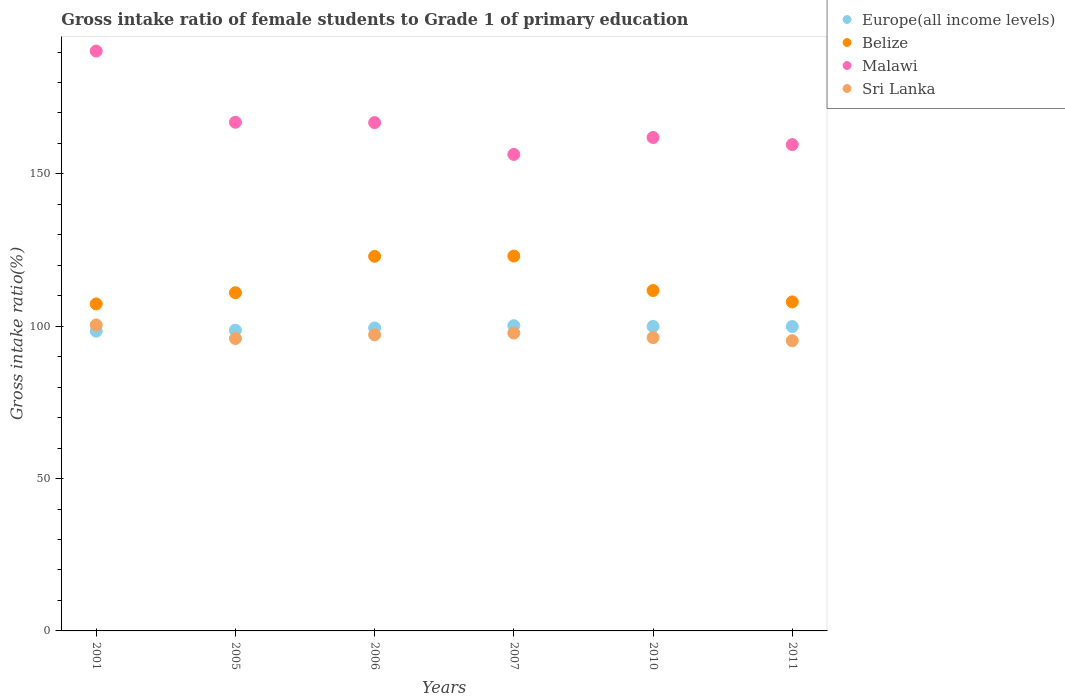How many different coloured dotlines are there?
Offer a very short reply. 4. What is the gross intake ratio in Sri Lanka in 2001?
Provide a succinct answer. 100.42. Across all years, what is the maximum gross intake ratio in Malawi?
Make the answer very short. 190.31. Across all years, what is the minimum gross intake ratio in Sri Lanka?
Give a very brief answer. 95.25. In which year was the gross intake ratio in Belize maximum?
Your response must be concise. 2007. What is the total gross intake ratio in Sri Lanka in the graph?
Your response must be concise. 582.84. What is the difference between the gross intake ratio in Belize in 2007 and that in 2011?
Keep it short and to the point. 15.05. What is the difference between the gross intake ratio in Belize in 2011 and the gross intake ratio in Sri Lanka in 2001?
Provide a short and direct response. 7.56. What is the average gross intake ratio in Europe(all income levels) per year?
Your answer should be compact. 99.42. In the year 2010, what is the difference between the gross intake ratio in Malawi and gross intake ratio in Belize?
Your response must be concise. 50.22. What is the ratio of the gross intake ratio in Sri Lanka in 2001 to that in 2010?
Your response must be concise. 1.04. Is the gross intake ratio in Europe(all income levels) in 2001 less than that in 2011?
Offer a terse response. Yes. Is the difference between the gross intake ratio in Malawi in 2005 and 2007 greater than the difference between the gross intake ratio in Belize in 2005 and 2007?
Your answer should be compact. Yes. What is the difference between the highest and the second highest gross intake ratio in Belize?
Your answer should be compact. 0.09. What is the difference between the highest and the lowest gross intake ratio in Europe(all income levels)?
Your answer should be compact. 1.79. Is it the case that in every year, the sum of the gross intake ratio in Belize and gross intake ratio in Europe(all income levels)  is greater than the sum of gross intake ratio in Malawi and gross intake ratio in Sri Lanka?
Provide a succinct answer. No. Is it the case that in every year, the sum of the gross intake ratio in Europe(all income levels) and gross intake ratio in Sri Lanka  is greater than the gross intake ratio in Belize?
Offer a very short reply. Yes. Does the gross intake ratio in Sri Lanka monotonically increase over the years?
Give a very brief answer. No. What is the difference between two consecutive major ticks on the Y-axis?
Give a very brief answer. 50. Are the values on the major ticks of Y-axis written in scientific E-notation?
Your answer should be compact. No. Where does the legend appear in the graph?
Provide a succinct answer. Top right. What is the title of the graph?
Give a very brief answer. Gross intake ratio of female students to Grade 1 of primary education. Does "Romania" appear as one of the legend labels in the graph?
Ensure brevity in your answer.  No. What is the label or title of the Y-axis?
Provide a short and direct response. Gross intake ratio(%). What is the Gross intake ratio(%) of Europe(all income levels) in 2001?
Offer a terse response. 98.39. What is the Gross intake ratio(%) in Belize in 2001?
Make the answer very short. 107.33. What is the Gross intake ratio(%) in Malawi in 2001?
Your answer should be compact. 190.31. What is the Gross intake ratio(%) in Sri Lanka in 2001?
Make the answer very short. 100.42. What is the Gross intake ratio(%) in Europe(all income levels) in 2005?
Provide a succinct answer. 98.7. What is the Gross intake ratio(%) of Belize in 2005?
Your answer should be compact. 111. What is the Gross intake ratio(%) of Malawi in 2005?
Ensure brevity in your answer.  166.94. What is the Gross intake ratio(%) of Sri Lanka in 2005?
Your answer should be compact. 95.96. What is the Gross intake ratio(%) in Europe(all income levels) in 2006?
Ensure brevity in your answer.  99.42. What is the Gross intake ratio(%) of Belize in 2006?
Provide a succinct answer. 122.94. What is the Gross intake ratio(%) in Malawi in 2006?
Your answer should be compact. 166.83. What is the Gross intake ratio(%) in Sri Lanka in 2006?
Ensure brevity in your answer.  97.18. What is the Gross intake ratio(%) in Europe(all income levels) in 2007?
Your answer should be compact. 100.18. What is the Gross intake ratio(%) in Belize in 2007?
Give a very brief answer. 123.03. What is the Gross intake ratio(%) in Malawi in 2007?
Your answer should be very brief. 156.38. What is the Gross intake ratio(%) in Sri Lanka in 2007?
Offer a very short reply. 97.76. What is the Gross intake ratio(%) in Europe(all income levels) in 2010?
Offer a terse response. 99.93. What is the Gross intake ratio(%) in Belize in 2010?
Your answer should be compact. 111.72. What is the Gross intake ratio(%) in Malawi in 2010?
Your answer should be compact. 161.95. What is the Gross intake ratio(%) in Sri Lanka in 2010?
Make the answer very short. 96.27. What is the Gross intake ratio(%) in Europe(all income levels) in 2011?
Provide a short and direct response. 99.91. What is the Gross intake ratio(%) in Belize in 2011?
Provide a short and direct response. 107.98. What is the Gross intake ratio(%) in Malawi in 2011?
Offer a very short reply. 159.61. What is the Gross intake ratio(%) of Sri Lanka in 2011?
Give a very brief answer. 95.25. Across all years, what is the maximum Gross intake ratio(%) in Europe(all income levels)?
Give a very brief answer. 100.18. Across all years, what is the maximum Gross intake ratio(%) in Belize?
Your answer should be very brief. 123.03. Across all years, what is the maximum Gross intake ratio(%) of Malawi?
Your answer should be very brief. 190.31. Across all years, what is the maximum Gross intake ratio(%) of Sri Lanka?
Your answer should be very brief. 100.42. Across all years, what is the minimum Gross intake ratio(%) of Europe(all income levels)?
Provide a succinct answer. 98.39. Across all years, what is the minimum Gross intake ratio(%) of Belize?
Ensure brevity in your answer.  107.33. Across all years, what is the minimum Gross intake ratio(%) of Malawi?
Offer a terse response. 156.38. Across all years, what is the minimum Gross intake ratio(%) of Sri Lanka?
Give a very brief answer. 95.25. What is the total Gross intake ratio(%) of Europe(all income levels) in the graph?
Keep it short and to the point. 596.53. What is the total Gross intake ratio(%) of Belize in the graph?
Keep it short and to the point. 684. What is the total Gross intake ratio(%) of Malawi in the graph?
Your answer should be very brief. 1002.03. What is the total Gross intake ratio(%) in Sri Lanka in the graph?
Make the answer very short. 582.84. What is the difference between the Gross intake ratio(%) in Europe(all income levels) in 2001 and that in 2005?
Your answer should be compact. -0.31. What is the difference between the Gross intake ratio(%) in Belize in 2001 and that in 2005?
Make the answer very short. -3.67. What is the difference between the Gross intake ratio(%) in Malawi in 2001 and that in 2005?
Ensure brevity in your answer.  23.37. What is the difference between the Gross intake ratio(%) in Sri Lanka in 2001 and that in 2005?
Give a very brief answer. 4.46. What is the difference between the Gross intake ratio(%) in Europe(all income levels) in 2001 and that in 2006?
Offer a very short reply. -1.03. What is the difference between the Gross intake ratio(%) of Belize in 2001 and that in 2006?
Provide a short and direct response. -15.62. What is the difference between the Gross intake ratio(%) of Malawi in 2001 and that in 2006?
Ensure brevity in your answer.  23.48. What is the difference between the Gross intake ratio(%) of Sri Lanka in 2001 and that in 2006?
Provide a succinct answer. 3.24. What is the difference between the Gross intake ratio(%) in Europe(all income levels) in 2001 and that in 2007?
Your response must be concise. -1.79. What is the difference between the Gross intake ratio(%) in Belize in 2001 and that in 2007?
Ensure brevity in your answer.  -15.71. What is the difference between the Gross intake ratio(%) in Malawi in 2001 and that in 2007?
Offer a very short reply. 33.93. What is the difference between the Gross intake ratio(%) of Sri Lanka in 2001 and that in 2007?
Give a very brief answer. 2.65. What is the difference between the Gross intake ratio(%) of Europe(all income levels) in 2001 and that in 2010?
Your answer should be very brief. -1.55. What is the difference between the Gross intake ratio(%) in Belize in 2001 and that in 2010?
Keep it short and to the point. -4.4. What is the difference between the Gross intake ratio(%) of Malawi in 2001 and that in 2010?
Offer a very short reply. 28.37. What is the difference between the Gross intake ratio(%) in Sri Lanka in 2001 and that in 2010?
Your answer should be compact. 4.15. What is the difference between the Gross intake ratio(%) in Europe(all income levels) in 2001 and that in 2011?
Provide a succinct answer. -1.53. What is the difference between the Gross intake ratio(%) of Belize in 2001 and that in 2011?
Keep it short and to the point. -0.65. What is the difference between the Gross intake ratio(%) of Malawi in 2001 and that in 2011?
Offer a terse response. 30.7. What is the difference between the Gross intake ratio(%) in Sri Lanka in 2001 and that in 2011?
Your answer should be compact. 5.17. What is the difference between the Gross intake ratio(%) of Europe(all income levels) in 2005 and that in 2006?
Your response must be concise. -0.72. What is the difference between the Gross intake ratio(%) in Belize in 2005 and that in 2006?
Keep it short and to the point. -11.94. What is the difference between the Gross intake ratio(%) of Malawi in 2005 and that in 2006?
Provide a succinct answer. 0.12. What is the difference between the Gross intake ratio(%) of Sri Lanka in 2005 and that in 2006?
Offer a very short reply. -1.22. What is the difference between the Gross intake ratio(%) in Europe(all income levels) in 2005 and that in 2007?
Offer a very short reply. -1.48. What is the difference between the Gross intake ratio(%) in Belize in 2005 and that in 2007?
Your response must be concise. -12.03. What is the difference between the Gross intake ratio(%) in Malawi in 2005 and that in 2007?
Provide a short and direct response. 10.56. What is the difference between the Gross intake ratio(%) of Sri Lanka in 2005 and that in 2007?
Give a very brief answer. -1.8. What is the difference between the Gross intake ratio(%) of Europe(all income levels) in 2005 and that in 2010?
Provide a short and direct response. -1.23. What is the difference between the Gross intake ratio(%) of Belize in 2005 and that in 2010?
Make the answer very short. -0.72. What is the difference between the Gross intake ratio(%) in Malawi in 2005 and that in 2010?
Your answer should be compact. 5. What is the difference between the Gross intake ratio(%) of Sri Lanka in 2005 and that in 2010?
Your response must be concise. -0.31. What is the difference between the Gross intake ratio(%) of Europe(all income levels) in 2005 and that in 2011?
Provide a succinct answer. -1.22. What is the difference between the Gross intake ratio(%) of Belize in 2005 and that in 2011?
Offer a terse response. 3.02. What is the difference between the Gross intake ratio(%) of Malawi in 2005 and that in 2011?
Offer a very short reply. 7.34. What is the difference between the Gross intake ratio(%) of Sri Lanka in 2005 and that in 2011?
Provide a short and direct response. 0.71. What is the difference between the Gross intake ratio(%) in Europe(all income levels) in 2006 and that in 2007?
Your answer should be compact. -0.76. What is the difference between the Gross intake ratio(%) of Belize in 2006 and that in 2007?
Ensure brevity in your answer.  -0.09. What is the difference between the Gross intake ratio(%) of Malawi in 2006 and that in 2007?
Provide a succinct answer. 10.45. What is the difference between the Gross intake ratio(%) in Sri Lanka in 2006 and that in 2007?
Ensure brevity in your answer.  -0.58. What is the difference between the Gross intake ratio(%) of Europe(all income levels) in 2006 and that in 2010?
Ensure brevity in your answer.  -0.51. What is the difference between the Gross intake ratio(%) of Belize in 2006 and that in 2010?
Your answer should be very brief. 11.22. What is the difference between the Gross intake ratio(%) in Malawi in 2006 and that in 2010?
Your answer should be compact. 4.88. What is the difference between the Gross intake ratio(%) in Sri Lanka in 2006 and that in 2010?
Offer a terse response. 0.91. What is the difference between the Gross intake ratio(%) in Europe(all income levels) in 2006 and that in 2011?
Offer a very short reply. -0.49. What is the difference between the Gross intake ratio(%) of Belize in 2006 and that in 2011?
Ensure brevity in your answer.  14.96. What is the difference between the Gross intake ratio(%) of Malawi in 2006 and that in 2011?
Provide a short and direct response. 7.22. What is the difference between the Gross intake ratio(%) of Sri Lanka in 2006 and that in 2011?
Provide a succinct answer. 1.93. What is the difference between the Gross intake ratio(%) of Europe(all income levels) in 2007 and that in 2010?
Your response must be concise. 0.25. What is the difference between the Gross intake ratio(%) of Belize in 2007 and that in 2010?
Keep it short and to the point. 11.31. What is the difference between the Gross intake ratio(%) of Malawi in 2007 and that in 2010?
Provide a short and direct response. -5.56. What is the difference between the Gross intake ratio(%) in Sri Lanka in 2007 and that in 2010?
Offer a terse response. 1.49. What is the difference between the Gross intake ratio(%) in Europe(all income levels) in 2007 and that in 2011?
Your answer should be compact. 0.27. What is the difference between the Gross intake ratio(%) of Belize in 2007 and that in 2011?
Offer a very short reply. 15.05. What is the difference between the Gross intake ratio(%) in Malawi in 2007 and that in 2011?
Your response must be concise. -3.23. What is the difference between the Gross intake ratio(%) of Sri Lanka in 2007 and that in 2011?
Offer a terse response. 2.52. What is the difference between the Gross intake ratio(%) of Europe(all income levels) in 2010 and that in 2011?
Provide a short and direct response. 0.02. What is the difference between the Gross intake ratio(%) of Belize in 2010 and that in 2011?
Provide a succinct answer. 3.74. What is the difference between the Gross intake ratio(%) in Malawi in 2010 and that in 2011?
Your answer should be very brief. 2.34. What is the difference between the Gross intake ratio(%) of Sri Lanka in 2010 and that in 2011?
Offer a very short reply. 1.02. What is the difference between the Gross intake ratio(%) in Europe(all income levels) in 2001 and the Gross intake ratio(%) in Belize in 2005?
Give a very brief answer. -12.61. What is the difference between the Gross intake ratio(%) in Europe(all income levels) in 2001 and the Gross intake ratio(%) in Malawi in 2005?
Offer a terse response. -68.56. What is the difference between the Gross intake ratio(%) in Europe(all income levels) in 2001 and the Gross intake ratio(%) in Sri Lanka in 2005?
Provide a short and direct response. 2.43. What is the difference between the Gross intake ratio(%) of Belize in 2001 and the Gross intake ratio(%) of Malawi in 2005?
Offer a very short reply. -59.62. What is the difference between the Gross intake ratio(%) in Belize in 2001 and the Gross intake ratio(%) in Sri Lanka in 2005?
Keep it short and to the point. 11.36. What is the difference between the Gross intake ratio(%) of Malawi in 2001 and the Gross intake ratio(%) of Sri Lanka in 2005?
Offer a terse response. 94.35. What is the difference between the Gross intake ratio(%) of Europe(all income levels) in 2001 and the Gross intake ratio(%) of Belize in 2006?
Provide a succinct answer. -24.56. What is the difference between the Gross intake ratio(%) in Europe(all income levels) in 2001 and the Gross intake ratio(%) in Malawi in 2006?
Offer a very short reply. -68.44. What is the difference between the Gross intake ratio(%) in Europe(all income levels) in 2001 and the Gross intake ratio(%) in Sri Lanka in 2006?
Your response must be concise. 1.2. What is the difference between the Gross intake ratio(%) in Belize in 2001 and the Gross intake ratio(%) in Malawi in 2006?
Keep it short and to the point. -59.5. What is the difference between the Gross intake ratio(%) of Belize in 2001 and the Gross intake ratio(%) of Sri Lanka in 2006?
Ensure brevity in your answer.  10.14. What is the difference between the Gross intake ratio(%) of Malawi in 2001 and the Gross intake ratio(%) of Sri Lanka in 2006?
Provide a succinct answer. 93.13. What is the difference between the Gross intake ratio(%) in Europe(all income levels) in 2001 and the Gross intake ratio(%) in Belize in 2007?
Keep it short and to the point. -24.65. What is the difference between the Gross intake ratio(%) in Europe(all income levels) in 2001 and the Gross intake ratio(%) in Malawi in 2007?
Provide a short and direct response. -58. What is the difference between the Gross intake ratio(%) of Europe(all income levels) in 2001 and the Gross intake ratio(%) of Sri Lanka in 2007?
Provide a short and direct response. 0.62. What is the difference between the Gross intake ratio(%) in Belize in 2001 and the Gross intake ratio(%) in Malawi in 2007?
Your response must be concise. -49.06. What is the difference between the Gross intake ratio(%) of Belize in 2001 and the Gross intake ratio(%) of Sri Lanka in 2007?
Make the answer very short. 9.56. What is the difference between the Gross intake ratio(%) of Malawi in 2001 and the Gross intake ratio(%) of Sri Lanka in 2007?
Keep it short and to the point. 92.55. What is the difference between the Gross intake ratio(%) of Europe(all income levels) in 2001 and the Gross intake ratio(%) of Belize in 2010?
Ensure brevity in your answer.  -13.34. What is the difference between the Gross intake ratio(%) in Europe(all income levels) in 2001 and the Gross intake ratio(%) in Malawi in 2010?
Keep it short and to the point. -63.56. What is the difference between the Gross intake ratio(%) in Europe(all income levels) in 2001 and the Gross intake ratio(%) in Sri Lanka in 2010?
Offer a terse response. 2.12. What is the difference between the Gross intake ratio(%) in Belize in 2001 and the Gross intake ratio(%) in Malawi in 2010?
Offer a very short reply. -54.62. What is the difference between the Gross intake ratio(%) in Belize in 2001 and the Gross intake ratio(%) in Sri Lanka in 2010?
Your answer should be very brief. 11.06. What is the difference between the Gross intake ratio(%) of Malawi in 2001 and the Gross intake ratio(%) of Sri Lanka in 2010?
Ensure brevity in your answer.  94.04. What is the difference between the Gross intake ratio(%) of Europe(all income levels) in 2001 and the Gross intake ratio(%) of Belize in 2011?
Give a very brief answer. -9.59. What is the difference between the Gross intake ratio(%) in Europe(all income levels) in 2001 and the Gross intake ratio(%) in Malawi in 2011?
Your response must be concise. -61.22. What is the difference between the Gross intake ratio(%) in Europe(all income levels) in 2001 and the Gross intake ratio(%) in Sri Lanka in 2011?
Ensure brevity in your answer.  3.14. What is the difference between the Gross intake ratio(%) of Belize in 2001 and the Gross intake ratio(%) of Malawi in 2011?
Ensure brevity in your answer.  -52.28. What is the difference between the Gross intake ratio(%) of Belize in 2001 and the Gross intake ratio(%) of Sri Lanka in 2011?
Make the answer very short. 12.08. What is the difference between the Gross intake ratio(%) in Malawi in 2001 and the Gross intake ratio(%) in Sri Lanka in 2011?
Your answer should be compact. 95.06. What is the difference between the Gross intake ratio(%) in Europe(all income levels) in 2005 and the Gross intake ratio(%) in Belize in 2006?
Your answer should be very brief. -24.25. What is the difference between the Gross intake ratio(%) in Europe(all income levels) in 2005 and the Gross intake ratio(%) in Malawi in 2006?
Your answer should be very brief. -68.13. What is the difference between the Gross intake ratio(%) of Europe(all income levels) in 2005 and the Gross intake ratio(%) of Sri Lanka in 2006?
Make the answer very short. 1.52. What is the difference between the Gross intake ratio(%) of Belize in 2005 and the Gross intake ratio(%) of Malawi in 2006?
Offer a terse response. -55.83. What is the difference between the Gross intake ratio(%) of Belize in 2005 and the Gross intake ratio(%) of Sri Lanka in 2006?
Your answer should be compact. 13.82. What is the difference between the Gross intake ratio(%) in Malawi in 2005 and the Gross intake ratio(%) in Sri Lanka in 2006?
Keep it short and to the point. 69.76. What is the difference between the Gross intake ratio(%) in Europe(all income levels) in 2005 and the Gross intake ratio(%) in Belize in 2007?
Your response must be concise. -24.34. What is the difference between the Gross intake ratio(%) of Europe(all income levels) in 2005 and the Gross intake ratio(%) of Malawi in 2007?
Provide a succinct answer. -57.69. What is the difference between the Gross intake ratio(%) in Europe(all income levels) in 2005 and the Gross intake ratio(%) in Sri Lanka in 2007?
Provide a succinct answer. 0.93. What is the difference between the Gross intake ratio(%) of Belize in 2005 and the Gross intake ratio(%) of Malawi in 2007?
Make the answer very short. -45.38. What is the difference between the Gross intake ratio(%) in Belize in 2005 and the Gross intake ratio(%) in Sri Lanka in 2007?
Provide a succinct answer. 13.24. What is the difference between the Gross intake ratio(%) in Malawi in 2005 and the Gross intake ratio(%) in Sri Lanka in 2007?
Provide a short and direct response. 69.18. What is the difference between the Gross intake ratio(%) of Europe(all income levels) in 2005 and the Gross intake ratio(%) of Belize in 2010?
Ensure brevity in your answer.  -13.03. What is the difference between the Gross intake ratio(%) of Europe(all income levels) in 2005 and the Gross intake ratio(%) of Malawi in 2010?
Provide a succinct answer. -63.25. What is the difference between the Gross intake ratio(%) of Europe(all income levels) in 2005 and the Gross intake ratio(%) of Sri Lanka in 2010?
Your response must be concise. 2.43. What is the difference between the Gross intake ratio(%) of Belize in 2005 and the Gross intake ratio(%) of Malawi in 2010?
Your response must be concise. -50.95. What is the difference between the Gross intake ratio(%) of Belize in 2005 and the Gross intake ratio(%) of Sri Lanka in 2010?
Your answer should be very brief. 14.73. What is the difference between the Gross intake ratio(%) of Malawi in 2005 and the Gross intake ratio(%) of Sri Lanka in 2010?
Your answer should be very brief. 70.68. What is the difference between the Gross intake ratio(%) of Europe(all income levels) in 2005 and the Gross intake ratio(%) of Belize in 2011?
Ensure brevity in your answer.  -9.28. What is the difference between the Gross intake ratio(%) of Europe(all income levels) in 2005 and the Gross intake ratio(%) of Malawi in 2011?
Ensure brevity in your answer.  -60.91. What is the difference between the Gross intake ratio(%) in Europe(all income levels) in 2005 and the Gross intake ratio(%) in Sri Lanka in 2011?
Your answer should be very brief. 3.45. What is the difference between the Gross intake ratio(%) of Belize in 2005 and the Gross intake ratio(%) of Malawi in 2011?
Offer a very short reply. -48.61. What is the difference between the Gross intake ratio(%) in Belize in 2005 and the Gross intake ratio(%) in Sri Lanka in 2011?
Provide a short and direct response. 15.75. What is the difference between the Gross intake ratio(%) of Malawi in 2005 and the Gross intake ratio(%) of Sri Lanka in 2011?
Offer a terse response. 71.7. What is the difference between the Gross intake ratio(%) in Europe(all income levels) in 2006 and the Gross intake ratio(%) in Belize in 2007?
Your answer should be very brief. -23.61. What is the difference between the Gross intake ratio(%) of Europe(all income levels) in 2006 and the Gross intake ratio(%) of Malawi in 2007?
Your answer should be compact. -56.96. What is the difference between the Gross intake ratio(%) in Europe(all income levels) in 2006 and the Gross intake ratio(%) in Sri Lanka in 2007?
Provide a short and direct response. 1.66. What is the difference between the Gross intake ratio(%) in Belize in 2006 and the Gross intake ratio(%) in Malawi in 2007?
Ensure brevity in your answer.  -33.44. What is the difference between the Gross intake ratio(%) of Belize in 2006 and the Gross intake ratio(%) of Sri Lanka in 2007?
Provide a short and direct response. 25.18. What is the difference between the Gross intake ratio(%) of Malawi in 2006 and the Gross intake ratio(%) of Sri Lanka in 2007?
Your answer should be very brief. 69.07. What is the difference between the Gross intake ratio(%) of Europe(all income levels) in 2006 and the Gross intake ratio(%) of Belize in 2010?
Provide a succinct answer. -12.3. What is the difference between the Gross intake ratio(%) in Europe(all income levels) in 2006 and the Gross intake ratio(%) in Malawi in 2010?
Your response must be concise. -62.53. What is the difference between the Gross intake ratio(%) in Europe(all income levels) in 2006 and the Gross intake ratio(%) in Sri Lanka in 2010?
Provide a short and direct response. 3.15. What is the difference between the Gross intake ratio(%) in Belize in 2006 and the Gross intake ratio(%) in Malawi in 2010?
Your answer should be compact. -39. What is the difference between the Gross intake ratio(%) of Belize in 2006 and the Gross intake ratio(%) of Sri Lanka in 2010?
Your answer should be compact. 26.67. What is the difference between the Gross intake ratio(%) in Malawi in 2006 and the Gross intake ratio(%) in Sri Lanka in 2010?
Your answer should be compact. 70.56. What is the difference between the Gross intake ratio(%) of Europe(all income levels) in 2006 and the Gross intake ratio(%) of Belize in 2011?
Your response must be concise. -8.56. What is the difference between the Gross intake ratio(%) of Europe(all income levels) in 2006 and the Gross intake ratio(%) of Malawi in 2011?
Make the answer very short. -60.19. What is the difference between the Gross intake ratio(%) of Europe(all income levels) in 2006 and the Gross intake ratio(%) of Sri Lanka in 2011?
Offer a very short reply. 4.17. What is the difference between the Gross intake ratio(%) in Belize in 2006 and the Gross intake ratio(%) in Malawi in 2011?
Keep it short and to the point. -36.67. What is the difference between the Gross intake ratio(%) in Belize in 2006 and the Gross intake ratio(%) in Sri Lanka in 2011?
Your answer should be very brief. 27.69. What is the difference between the Gross intake ratio(%) of Malawi in 2006 and the Gross intake ratio(%) of Sri Lanka in 2011?
Offer a terse response. 71.58. What is the difference between the Gross intake ratio(%) in Europe(all income levels) in 2007 and the Gross intake ratio(%) in Belize in 2010?
Give a very brief answer. -11.54. What is the difference between the Gross intake ratio(%) of Europe(all income levels) in 2007 and the Gross intake ratio(%) of Malawi in 2010?
Ensure brevity in your answer.  -61.77. What is the difference between the Gross intake ratio(%) of Europe(all income levels) in 2007 and the Gross intake ratio(%) of Sri Lanka in 2010?
Your answer should be compact. 3.91. What is the difference between the Gross intake ratio(%) in Belize in 2007 and the Gross intake ratio(%) in Malawi in 2010?
Provide a short and direct response. -38.91. What is the difference between the Gross intake ratio(%) of Belize in 2007 and the Gross intake ratio(%) of Sri Lanka in 2010?
Offer a very short reply. 26.76. What is the difference between the Gross intake ratio(%) in Malawi in 2007 and the Gross intake ratio(%) in Sri Lanka in 2010?
Your response must be concise. 60.11. What is the difference between the Gross intake ratio(%) of Europe(all income levels) in 2007 and the Gross intake ratio(%) of Belize in 2011?
Your response must be concise. -7.8. What is the difference between the Gross intake ratio(%) in Europe(all income levels) in 2007 and the Gross intake ratio(%) in Malawi in 2011?
Your answer should be compact. -59.43. What is the difference between the Gross intake ratio(%) in Europe(all income levels) in 2007 and the Gross intake ratio(%) in Sri Lanka in 2011?
Provide a succinct answer. 4.93. What is the difference between the Gross intake ratio(%) of Belize in 2007 and the Gross intake ratio(%) of Malawi in 2011?
Your response must be concise. -36.58. What is the difference between the Gross intake ratio(%) in Belize in 2007 and the Gross intake ratio(%) in Sri Lanka in 2011?
Make the answer very short. 27.79. What is the difference between the Gross intake ratio(%) in Malawi in 2007 and the Gross intake ratio(%) in Sri Lanka in 2011?
Your response must be concise. 61.13. What is the difference between the Gross intake ratio(%) of Europe(all income levels) in 2010 and the Gross intake ratio(%) of Belize in 2011?
Ensure brevity in your answer.  -8.05. What is the difference between the Gross intake ratio(%) of Europe(all income levels) in 2010 and the Gross intake ratio(%) of Malawi in 2011?
Offer a terse response. -59.68. What is the difference between the Gross intake ratio(%) in Europe(all income levels) in 2010 and the Gross intake ratio(%) in Sri Lanka in 2011?
Your answer should be very brief. 4.68. What is the difference between the Gross intake ratio(%) in Belize in 2010 and the Gross intake ratio(%) in Malawi in 2011?
Ensure brevity in your answer.  -47.89. What is the difference between the Gross intake ratio(%) in Belize in 2010 and the Gross intake ratio(%) in Sri Lanka in 2011?
Make the answer very short. 16.47. What is the difference between the Gross intake ratio(%) of Malawi in 2010 and the Gross intake ratio(%) of Sri Lanka in 2011?
Make the answer very short. 66.7. What is the average Gross intake ratio(%) in Europe(all income levels) per year?
Offer a very short reply. 99.42. What is the average Gross intake ratio(%) of Belize per year?
Your answer should be very brief. 114. What is the average Gross intake ratio(%) in Malawi per year?
Ensure brevity in your answer.  167. What is the average Gross intake ratio(%) of Sri Lanka per year?
Your answer should be very brief. 97.14. In the year 2001, what is the difference between the Gross intake ratio(%) in Europe(all income levels) and Gross intake ratio(%) in Belize?
Keep it short and to the point. -8.94. In the year 2001, what is the difference between the Gross intake ratio(%) of Europe(all income levels) and Gross intake ratio(%) of Malawi?
Keep it short and to the point. -91.93. In the year 2001, what is the difference between the Gross intake ratio(%) in Europe(all income levels) and Gross intake ratio(%) in Sri Lanka?
Your response must be concise. -2.03. In the year 2001, what is the difference between the Gross intake ratio(%) of Belize and Gross intake ratio(%) of Malawi?
Provide a succinct answer. -82.99. In the year 2001, what is the difference between the Gross intake ratio(%) of Belize and Gross intake ratio(%) of Sri Lanka?
Make the answer very short. 6.91. In the year 2001, what is the difference between the Gross intake ratio(%) of Malawi and Gross intake ratio(%) of Sri Lanka?
Offer a very short reply. 89.89. In the year 2005, what is the difference between the Gross intake ratio(%) in Europe(all income levels) and Gross intake ratio(%) in Belize?
Offer a very short reply. -12.3. In the year 2005, what is the difference between the Gross intake ratio(%) in Europe(all income levels) and Gross intake ratio(%) in Malawi?
Your answer should be compact. -68.25. In the year 2005, what is the difference between the Gross intake ratio(%) in Europe(all income levels) and Gross intake ratio(%) in Sri Lanka?
Give a very brief answer. 2.74. In the year 2005, what is the difference between the Gross intake ratio(%) in Belize and Gross intake ratio(%) in Malawi?
Offer a very short reply. -55.94. In the year 2005, what is the difference between the Gross intake ratio(%) in Belize and Gross intake ratio(%) in Sri Lanka?
Provide a short and direct response. 15.04. In the year 2005, what is the difference between the Gross intake ratio(%) of Malawi and Gross intake ratio(%) of Sri Lanka?
Your answer should be very brief. 70.98. In the year 2006, what is the difference between the Gross intake ratio(%) of Europe(all income levels) and Gross intake ratio(%) of Belize?
Offer a terse response. -23.52. In the year 2006, what is the difference between the Gross intake ratio(%) of Europe(all income levels) and Gross intake ratio(%) of Malawi?
Make the answer very short. -67.41. In the year 2006, what is the difference between the Gross intake ratio(%) in Europe(all income levels) and Gross intake ratio(%) in Sri Lanka?
Give a very brief answer. 2.24. In the year 2006, what is the difference between the Gross intake ratio(%) of Belize and Gross intake ratio(%) of Malawi?
Keep it short and to the point. -43.89. In the year 2006, what is the difference between the Gross intake ratio(%) in Belize and Gross intake ratio(%) in Sri Lanka?
Offer a very short reply. 25.76. In the year 2006, what is the difference between the Gross intake ratio(%) in Malawi and Gross intake ratio(%) in Sri Lanka?
Ensure brevity in your answer.  69.65. In the year 2007, what is the difference between the Gross intake ratio(%) in Europe(all income levels) and Gross intake ratio(%) in Belize?
Keep it short and to the point. -22.85. In the year 2007, what is the difference between the Gross intake ratio(%) of Europe(all income levels) and Gross intake ratio(%) of Malawi?
Offer a very short reply. -56.2. In the year 2007, what is the difference between the Gross intake ratio(%) in Europe(all income levels) and Gross intake ratio(%) in Sri Lanka?
Your answer should be very brief. 2.42. In the year 2007, what is the difference between the Gross intake ratio(%) of Belize and Gross intake ratio(%) of Malawi?
Offer a terse response. -33.35. In the year 2007, what is the difference between the Gross intake ratio(%) of Belize and Gross intake ratio(%) of Sri Lanka?
Give a very brief answer. 25.27. In the year 2007, what is the difference between the Gross intake ratio(%) of Malawi and Gross intake ratio(%) of Sri Lanka?
Provide a succinct answer. 58.62. In the year 2010, what is the difference between the Gross intake ratio(%) of Europe(all income levels) and Gross intake ratio(%) of Belize?
Your response must be concise. -11.79. In the year 2010, what is the difference between the Gross intake ratio(%) of Europe(all income levels) and Gross intake ratio(%) of Malawi?
Make the answer very short. -62.02. In the year 2010, what is the difference between the Gross intake ratio(%) of Europe(all income levels) and Gross intake ratio(%) of Sri Lanka?
Provide a succinct answer. 3.66. In the year 2010, what is the difference between the Gross intake ratio(%) in Belize and Gross intake ratio(%) in Malawi?
Your response must be concise. -50.22. In the year 2010, what is the difference between the Gross intake ratio(%) of Belize and Gross intake ratio(%) of Sri Lanka?
Keep it short and to the point. 15.45. In the year 2010, what is the difference between the Gross intake ratio(%) in Malawi and Gross intake ratio(%) in Sri Lanka?
Your response must be concise. 65.68. In the year 2011, what is the difference between the Gross intake ratio(%) of Europe(all income levels) and Gross intake ratio(%) of Belize?
Give a very brief answer. -8.06. In the year 2011, what is the difference between the Gross intake ratio(%) of Europe(all income levels) and Gross intake ratio(%) of Malawi?
Give a very brief answer. -59.7. In the year 2011, what is the difference between the Gross intake ratio(%) in Europe(all income levels) and Gross intake ratio(%) in Sri Lanka?
Keep it short and to the point. 4.67. In the year 2011, what is the difference between the Gross intake ratio(%) of Belize and Gross intake ratio(%) of Malawi?
Your response must be concise. -51.63. In the year 2011, what is the difference between the Gross intake ratio(%) in Belize and Gross intake ratio(%) in Sri Lanka?
Your response must be concise. 12.73. In the year 2011, what is the difference between the Gross intake ratio(%) in Malawi and Gross intake ratio(%) in Sri Lanka?
Provide a short and direct response. 64.36. What is the ratio of the Gross intake ratio(%) in Belize in 2001 to that in 2005?
Provide a succinct answer. 0.97. What is the ratio of the Gross intake ratio(%) of Malawi in 2001 to that in 2005?
Provide a succinct answer. 1.14. What is the ratio of the Gross intake ratio(%) in Sri Lanka in 2001 to that in 2005?
Provide a short and direct response. 1.05. What is the ratio of the Gross intake ratio(%) of Europe(all income levels) in 2001 to that in 2006?
Provide a succinct answer. 0.99. What is the ratio of the Gross intake ratio(%) of Belize in 2001 to that in 2006?
Make the answer very short. 0.87. What is the ratio of the Gross intake ratio(%) of Malawi in 2001 to that in 2006?
Your answer should be compact. 1.14. What is the ratio of the Gross intake ratio(%) in Europe(all income levels) in 2001 to that in 2007?
Provide a short and direct response. 0.98. What is the ratio of the Gross intake ratio(%) in Belize in 2001 to that in 2007?
Give a very brief answer. 0.87. What is the ratio of the Gross intake ratio(%) in Malawi in 2001 to that in 2007?
Keep it short and to the point. 1.22. What is the ratio of the Gross intake ratio(%) of Sri Lanka in 2001 to that in 2007?
Your response must be concise. 1.03. What is the ratio of the Gross intake ratio(%) in Europe(all income levels) in 2001 to that in 2010?
Provide a succinct answer. 0.98. What is the ratio of the Gross intake ratio(%) of Belize in 2001 to that in 2010?
Provide a short and direct response. 0.96. What is the ratio of the Gross intake ratio(%) of Malawi in 2001 to that in 2010?
Your answer should be very brief. 1.18. What is the ratio of the Gross intake ratio(%) in Sri Lanka in 2001 to that in 2010?
Provide a succinct answer. 1.04. What is the ratio of the Gross intake ratio(%) of Europe(all income levels) in 2001 to that in 2011?
Offer a terse response. 0.98. What is the ratio of the Gross intake ratio(%) of Malawi in 2001 to that in 2011?
Keep it short and to the point. 1.19. What is the ratio of the Gross intake ratio(%) of Sri Lanka in 2001 to that in 2011?
Provide a short and direct response. 1.05. What is the ratio of the Gross intake ratio(%) of Europe(all income levels) in 2005 to that in 2006?
Offer a terse response. 0.99. What is the ratio of the Gross intake ratio(%) of Belize in 2005 to that in 2006?
Offer a very short reply. 0.9. What is the ratio of the Gross intake ratio(%) in Sri Lanka in 2005 to that in 2006?
Make the answer very short. 0.99. What is the ratio of the Gross intake ratio(%) of Europe(all income levels) in 2005 to that in 2007?
Give a very brief answer. 0.99. What is the ratio of the Gross intake ratio(%) of Belize in 2005 to that in 2007?
Provide a short and direct response. 0.9. What is the ratio of the Gross intake ratio(%) in Malawi in 2005 to that in 2007?
Ensure brevity in your answer.  1.07. What is the ratio of the Gross intake ratio(%) of Sri Lanka in 2005 to that in 2007?
Offer a very short reply. 0.98. What is the ratio of the Gross intake ratio(%) in Europe(all income levels) in 2005 to that in 2010?
Offer a very short reply. 0.99. What is the ratio of the Gross intake ratio(%) in Malawi in 2005 to that in 2010?
Provide a succinct answer. 1.03. What is the ratio of the Gross intake ratio(%) of Belize in 2005 to that in 2011?
Offer a terse response. 1.03. What is the ratio of the Gross intake ratio(%) in Malawi in 2005 to that in 2011?
Give a very brief answer. 1.05. What is the ratio of the Gross intake ratio(%) in Sri Lanka in 2005 to that in 2011?
Your answer should be very brief. 1.01. What is the ratio of the Gross intake ratio(%) of Malawi in 2006 to that in 2007?
Your answer should be very brief. 1.07. What is the ratio of the Gross intake ratio(%) of Sri Lanka in 2006 to that in 2007?
Make the answer very short. 0.99. What is the ratio of the Gross intake ratio(%) in Belize in 2006 to that in 2010?
Your answer should be compact. 1.1. What is the ratio of the Gross intake ratio(%) in Malawi in 2006 to that in 2010?
Provide a succinct answer. 1.03. What is the ratio of the Gross intake ratio(%) of Sri Lanka in 2006 to that in 2010?
Offer a very short reply. 1.01. What is the ratio of the Gross intake ratio(%) in Europe(all income levels) in 2006 to that in 2011?
Keep it short and to the point. 1. What is the ratio of the Gross intake ratio(%) of Belize in 2006 to that in 2011?
Your response must be concise. 1.14. What is the ratio of the Gross intake ratio(%) of Malawi in 2006 to that in 2011?
Provide a succinct answer. 1.05. What is the ratio of the Gross intake ratio(%) in Sri Lanka in 2006 to that in 2011?
Give a very brief answer. 1.02. What is the ratio of the Gross intake ratio(%) in Belize in 2007 to that in 2010?
Make the answer very short. 1.1. What is the ratio of the Gross intake ratio(%) in Malawi in 2007 to that in 2010?
Offer a terse response. 0.97. What is the ratio of the Gross intake ratio(%) in Sri Lanka in 2007 to that in 2010?
Offer a very short reply. 1.02. What is the ratio of the Gross intake ratio(%) in Belize in 2007 to that in 2011?
Give a very brief answer. 1.14. What is the ratio of the Gross intake ratio(%) of Malawi in 2007 to that in 2011?
Your answer should be very brief. 0.98. What is the ratio of the Gross intake ratio(%) in Sri Lanka in 2007 to that in 2011?
Your answer should be compact. 1.03. What is the ratio of the Gross intake ratio(%) of Belize in 2010 to that in 2011?
Make the answer very short. 1.03. What is the ratio of the Gross intake ratio(%) in Malawi in 2010 to that in 2011?
Your answer should be compact. 1.01. What is the ratio of the Gross intake ratio(%) of Sri Lanka in 2010 to that in 2011?
Give a very brief answer. 1.01. What is the difference between the highest and the second highest Gross intake ratio(%) in Europe(all income levels)?
Your answer should be compact. 0.25. What is the difference between the highest and the second highest Gross intake ratio(%) in Belize?
Your answer should be compact. 0.09. What is the difference between the highest and the second highest Gross intake ratio(%) of Malawi?
Ensure brevity in your answer.  23.37. What is the difference between the highest and the second highest Gross intake ratio(%) in Sri Lanka?
Ensure brevity in your answer.  2.65. What is the difference between the highest and the lowest Gross intake ratio(%) of Europe(all income levels)?
Give a very brief answer. 1.79. What is the difference between the highest and the lowest Gross intake ratio(%) of Belize?
Offer a very short reply. 15.71. What is the difference between the highest and the lowest Gross intake ratio(%) of Malawi?
Your response must be concise. 33.93. What is the difference between the highest and the lowest Gross intake ratio(%) in Sri Lanka?
Your answer should be compact. 5.17. 